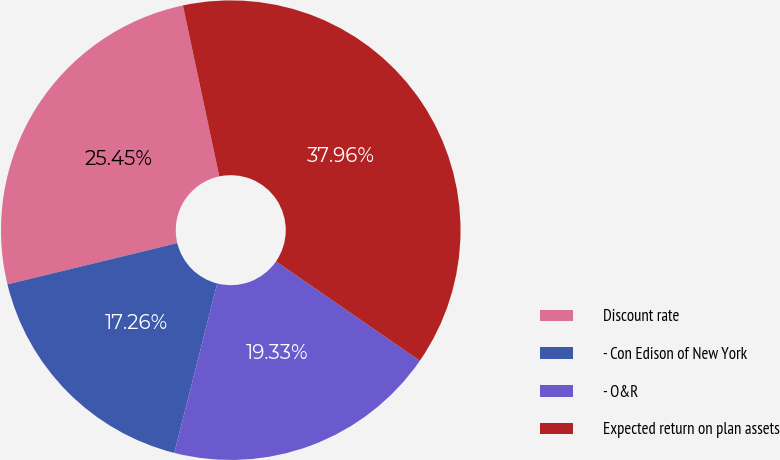<chart> <loc_0><loc_0><loc_500><loc_500><pie_chart><fcel>Discount rate<fcel>- Con Edison of New York<fcel>- O&R<fcel>Expected return on plan assets<nl><fcel>25.45%<fcel>17.26%<fcel>19.33%<fcel>37.96%<nl></chart> 